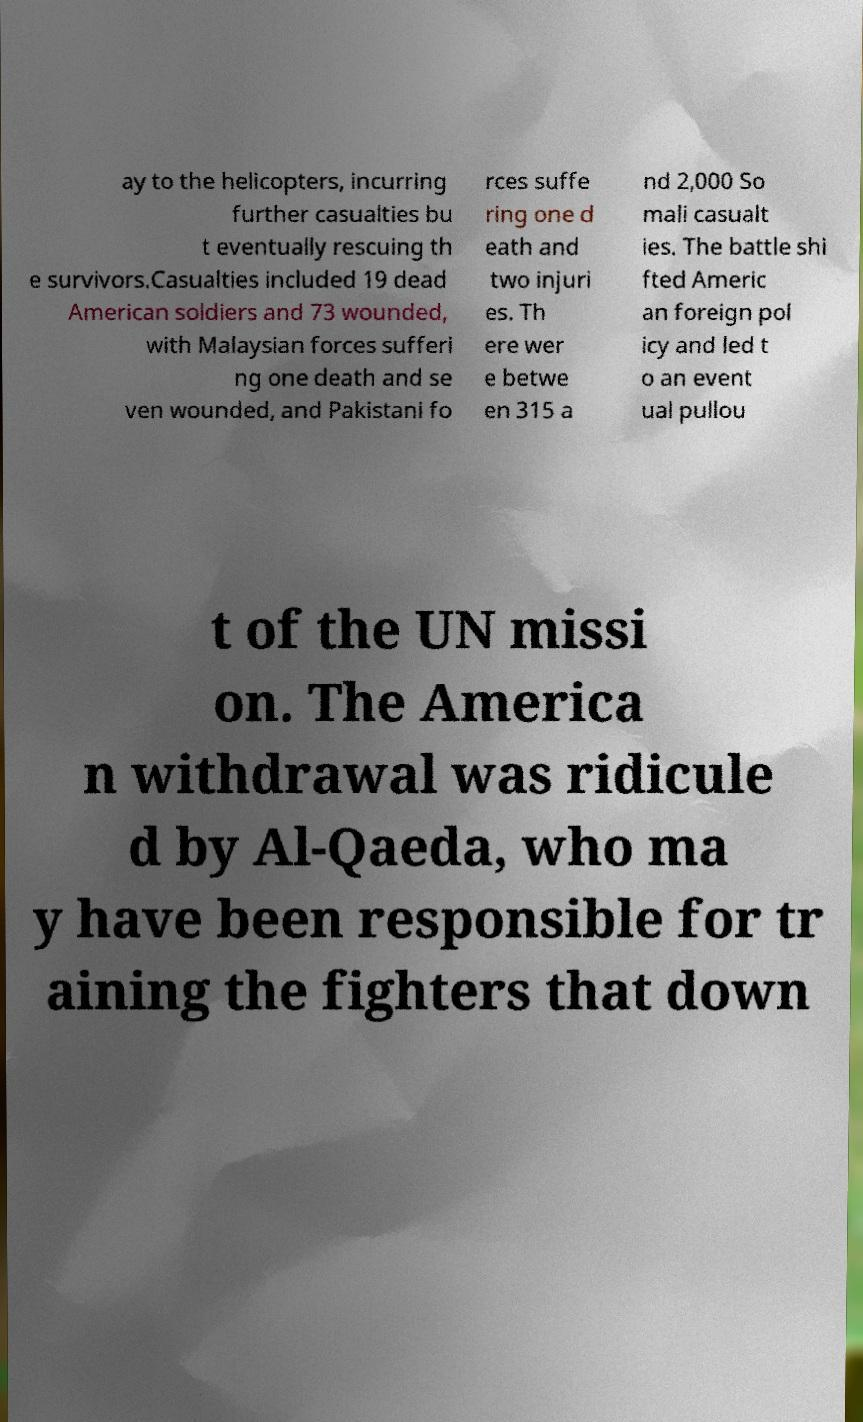Could you extract and type out the text from this image? ay to the helicopters, incurring further casualties bu t eventually rescuing th e survivors.Casualties included 19 dead American soldiers and 73 wounded, with Malaysian forces sufferi ng one death and se ven wounded, and Pakistani fo rces suffe ring one d eath and two injuri es. Th ere wer e betwe en 315 a nd 2,000 So mali casualt ies. The battle shi fted Americ an foreign pol icy and led t o an event ual pullou t of the UN missi on. The America n withdrawal was ridicule d by Al-Qaeda, who ma y have been responsible for tr aining the fighters that down 